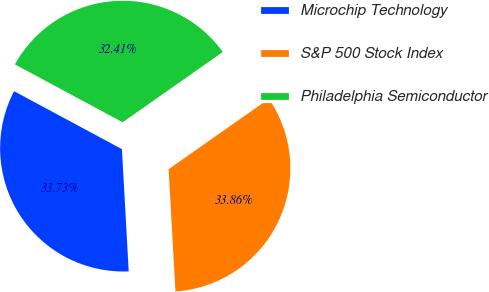Convert chart to OTSL. <chart><loc_0><loc_0><loc_500><loc_500><pie_chart><fcel>Microchip Technology<fcel>S&P 500 Stock Index<fcel>Philadelphia Semiconductor<nl><fcel>33.73%<fcel>33.86%<fcel>32.41%<nl></chart> 